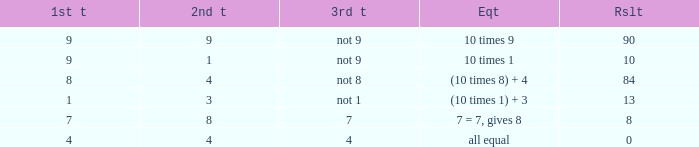Could you parse the entire table as a dict? {'header': ['1st t', '2nd t', '3rd t', 'Eqt', 'Rslt'], 'rows': [['9', '9', 'not 9', '10 times 9', '90'], ['9', '1', 'not 9', '10 times 1', '10'], ['8', '4', 'not 8', '(10 times 8) + 4', '84'], ['1', '3', 'not 1', '(10 times 1) + 3', '13'], ['7', '8', '7', '7 = 7, gives 8', '8'], ['4', '4', '4', 'all equal', '0']]} If the equation is (10 times 8) + 4, what would be the 2nd throw? 4.0. 